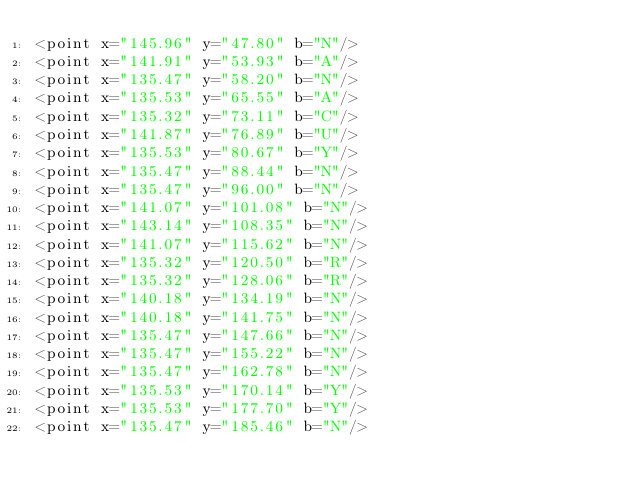<code> <loc_0><loc_0><loc_500><loc_500><_XML_><point x="145.96" y="47.80" b="N"/>
<point x="141.91" y="53.93" b="A"/>
<point x="135.47" y="58.20" b="N"/>
<point x="135.53" y="65.55" b="A"/>
<point x="135.32" y="73.11" b="C"/>
<point x="141.87" y="76.89" b="U"/>
<point x="135.53" y="80.67" b="Y"/>
<point x="135.47" y="88.44" b="N"/>
<point x="135.47" y="96.00" b="N"/>
<point x="141.07" y="101.08" b="N"/>
<point x="143.14" y="108.35" b="N"/>
<point x="141.07" y="115.62" b="N"/>
<point x="135.32" y="120.50" b="R"/>
<point x="135.32" y="128.06" b="R"/>
<point x="140.18" y="134.19" b="N"/>
<point x="140.18" y="141.75" b="N"/>
<point x="135.47" y="147.66" b="N"/>
<point x="135.47" y="155.22" b="N"/>
<point x="135.47" y="162.78" b="N"/>
<point x="135.53" y="170.14" b="Y"/>
<point x="135.53" y="177.70" b="Y"/>
<point x="135.47" y="185.46" b="N"/></code> 